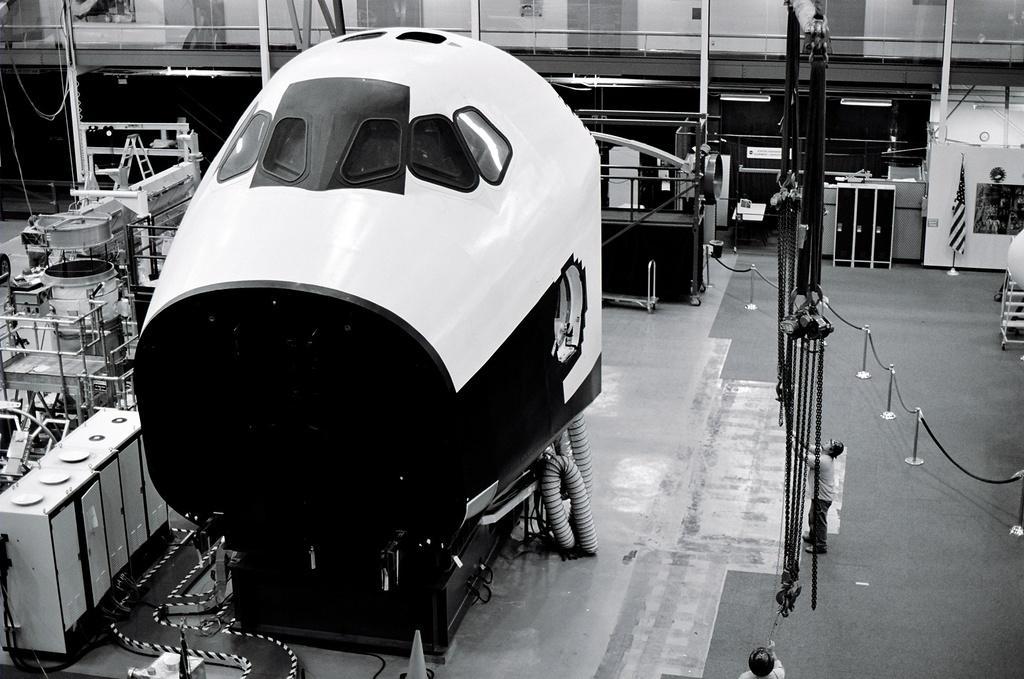In one or two sentences, can you explain what this image depicts? In the image in the center, we can see one electronic machine. In the background, we can see tools, tables, poles, fences, one flag, one person standing and a few other objects. 